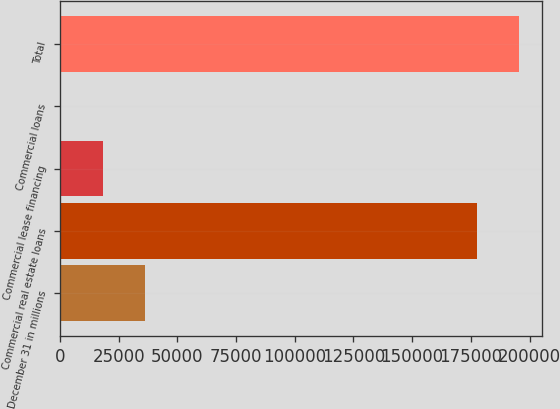Convert chart. <chart><loc_0><loc_0><loc_500><loc_500><bar_chart><fcel>December 31 in millions<fcel>Commercial real estate loans<fcel>Commercial lease financing<fcel>Commercial loans<fcel>Total<nl><fcel>36016.6<fcel>177731<fcel>18171.8<fcel>327<fcel>195576<nl></chart> 